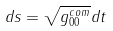Convert formula to latex. <formula><loc_0><loc_0><loc_500><loc_500>d s = \sqrt { g _ { 0 0 } ^ { c o m } } d t</formula> 